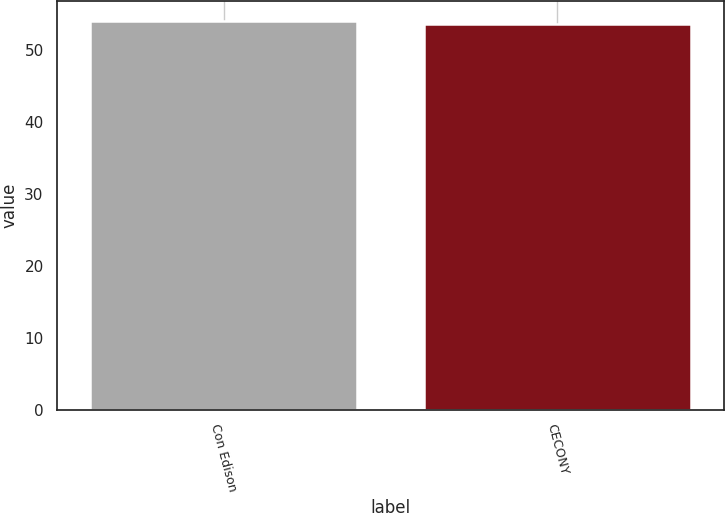Convert chart. <chart><loc_0><loc_0><loc_500><loc_500><bar_chart><fcel>Con Edison<fcel>CECONY<nl><fcel>54.1<fcel>53.6<nl></chart> 